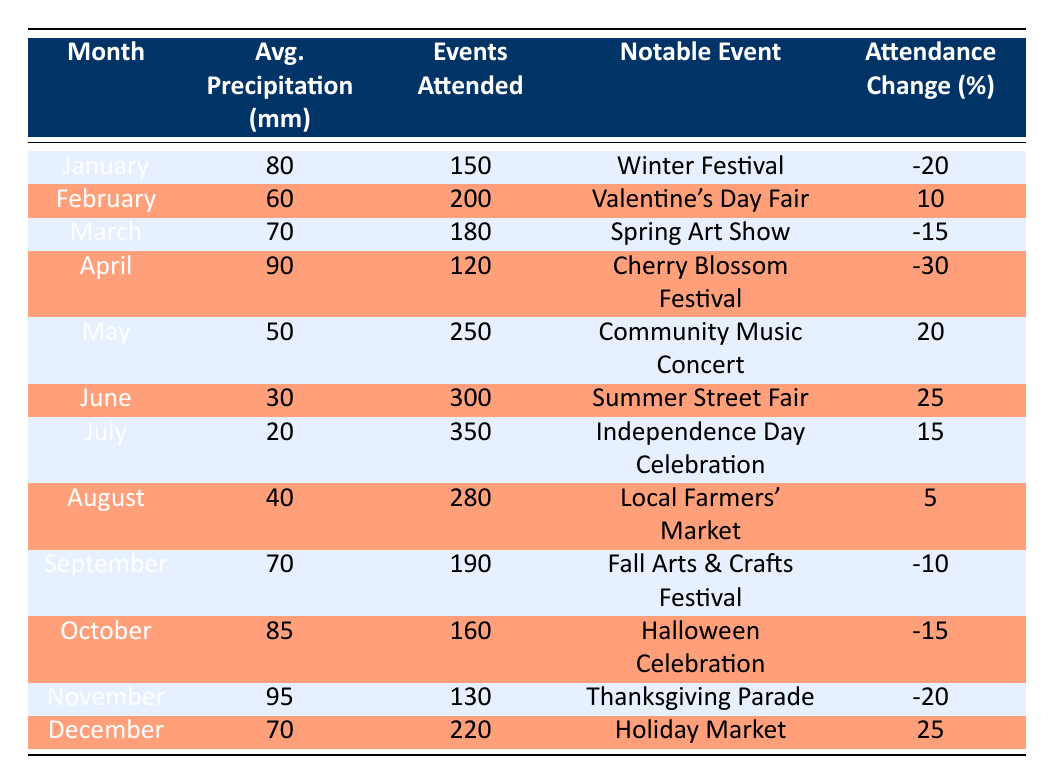What month had the highest average precipitation levels? By scanning through the column for average precipitation, we find that November has the highest recorded amount at 95 mm.
Answer: November Which notable event occurred in June? The table shows that the notable event for June is the Summer Street Fair.
Answer: Summer Street Fair How many local events were attended in May? The table states that a total of 250 events were attended in May.
Answer: 250 Was there an increase in attendance for the Valentine's Day Fair compared to the previous month? Comparing February's attendance (200) to January's (150), there was an increase of 50 participants, equating to a 10% change, so yes, attendance increased.
Answer: Yes What was the average precipitation for the months with events that saw attendance drop? The months with attendance drops are January, March, April, September, October, and November. Their respective precipitation values (80, 70, 90, 70, 85, 95) average to (80 + 70 + 90 + 70 + 85 + 95) / 6 = 82.5 mm.
Answer: 82.5 mm Did July have lower attendance than August? July's attendance is listed as 350, while August's is 280, indicating July had higher attendance than August.
Answer: No What percentage change in attendance was experienced during the Independence Day Celebration? The table notes a 15% increase in attendance during the July event, indicating a positive change.
Answer: 15% Calculate the total number of events attended from May to August. Adding the attendance from May (250), June (300), July (350), and August (280) yields 250 + 300 + 350 + 280 = 1180.
Answer: 1180 What is the notable event for October? The table indicates that the notable event for October is the Halloween Celebration.
Answer: Halloween Celebration 